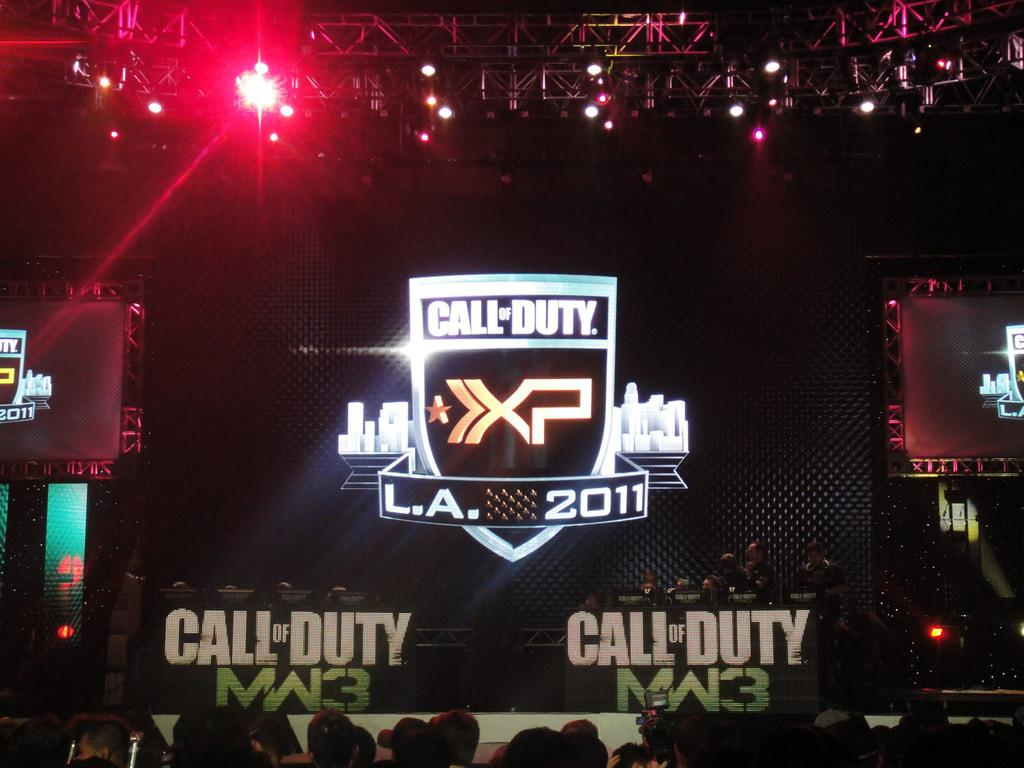<image>
Provide a brief description of the given image. An audience sits at a Call of Duty XP convention in L.A 2011. 